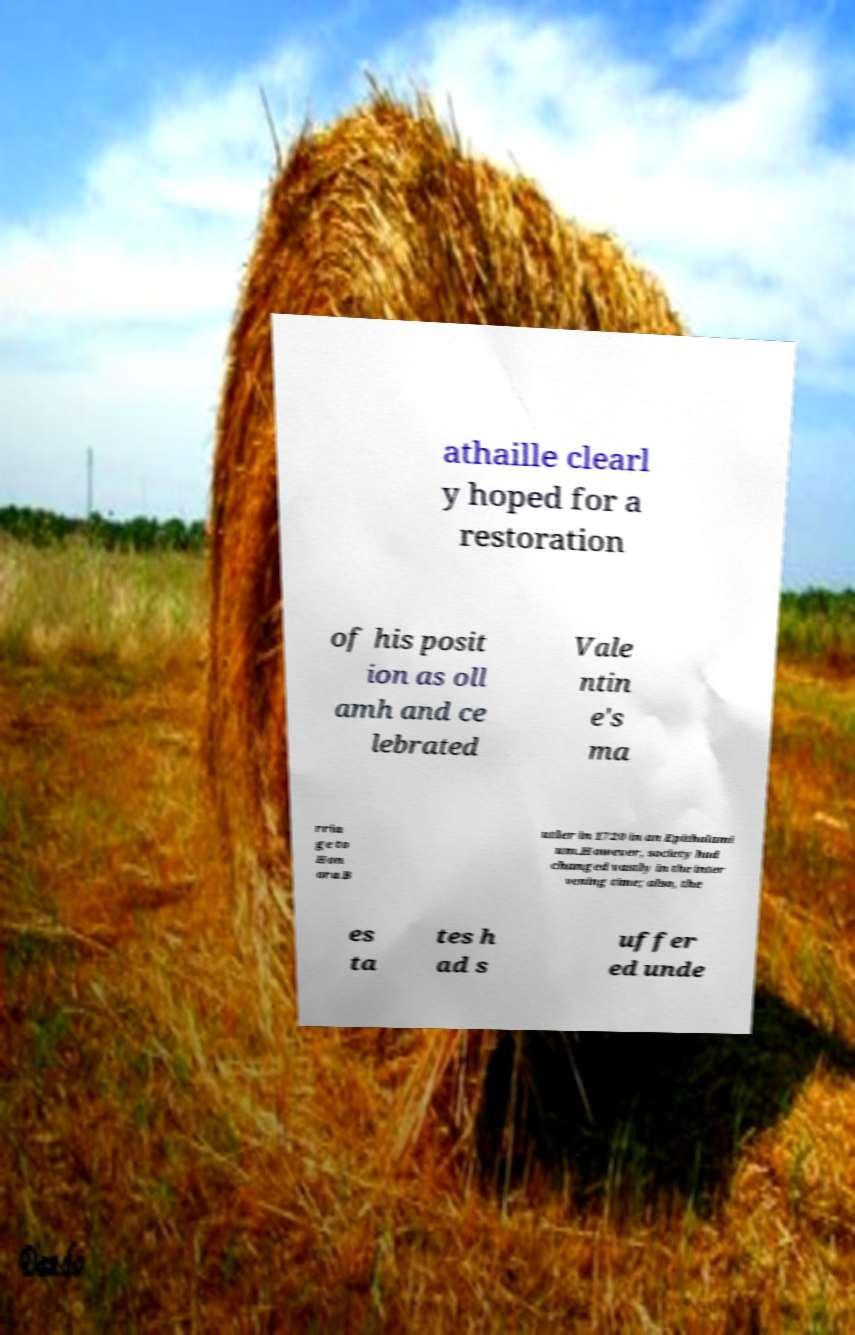There's text embedded in this image that I need extracted. Can you transcribe it verbatim? athaille clearl y hoped for a restoration of his posit ion as oll amh and ce lebrated Vale ntin e's ma rria ge to Hon ora B utler in 1720 in an Epithalami um.However, society had changed vastly in the inter vening time; also, the es ta tes h ad s uffer ed unde 